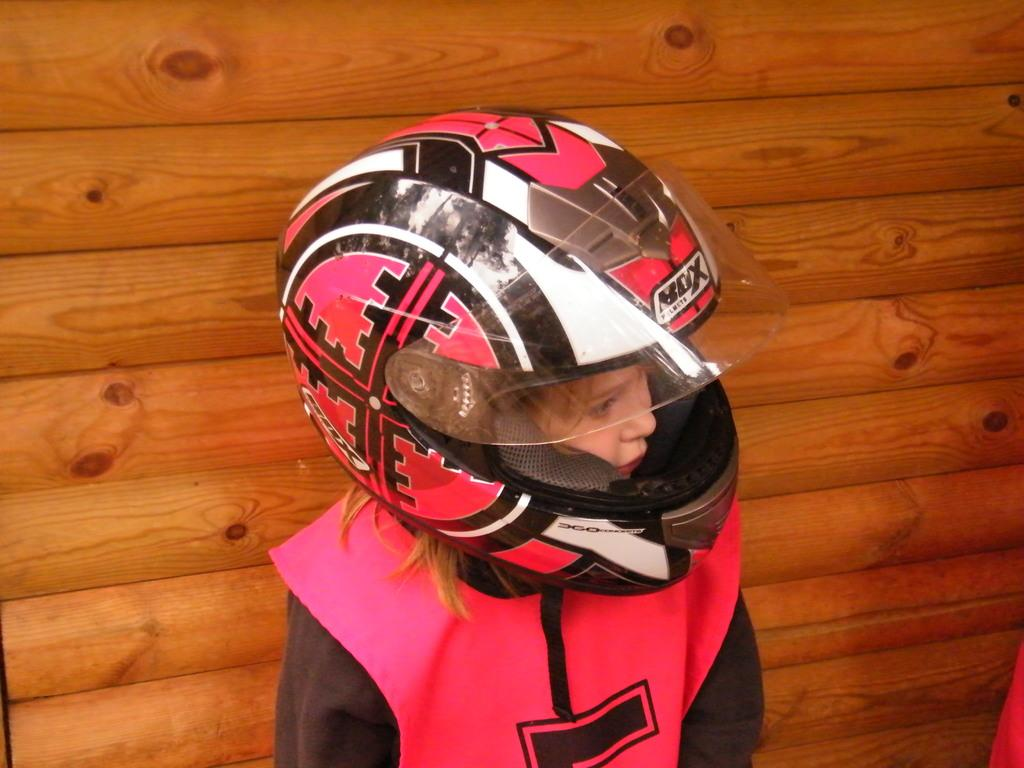What is the main subject of the image? There is a child in the image. What is the child wearing on their upper body? The child is wearing a pink jacket. What type of protective gear is the child wearing? The child is wearing a helmet. What can be seen in the background of the image? There is a wooden wall in the background of the image. What type of trousers is the child wearing in the image? The provided facts do not mention the type of trousers the child is wearing. However, we can see that the child is wearing a pink jacket. --- Facts: 1. There is a car in the image. 2. The car is red. 3. The car has four wheels. 4. There is a road in the image. 5. The road is paved. Absurd Topics: ocean, parrot, dance Conversation: What is the main subject of the image? There is a car in the image. What color is the car? The car is red. How many wheels does the car have? The car has four wheels. What type of surface is the car on? There is a road in the image, and it is paved. Reasoning: Let's think step by step in order to produce the conversation. We start by identifying the main subject of the image, which is the car. Then, we describe the car's color and the number of wheels it has. Finally, we mention the road and its paved surface to provide context for the setting. Absurd Question/Answer: Can you see any parrots flying over the ocean in the image? There is no ocean or parrot present in the image; it features a red car on a paved road. 